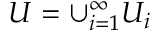<formula> <loc_0><loc_0><loc_500><loc_500>U = \cup _ { i = 1 } ^ { \infty } U _ { i }</formula> 